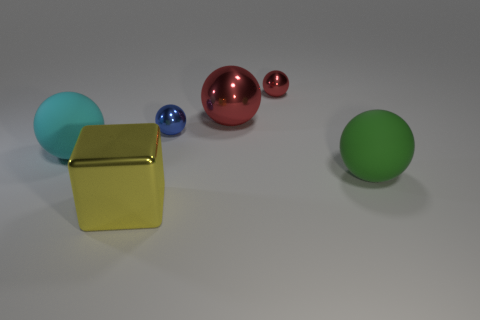Subtract all gray blocks. How many red balls are left? 2 Subtract all small blue metallic balls. How many balls are left? 4 Subtract 3 balls. How many balls are left? 2 Add 3 yellow metal things. How many objects exist? 9 Subtract all red balls. How many balls are left? 3 Subtract all purple spheres. Subtract all cyan cubes. How many spheres are left? 5 Subtract all spheres. How many objects are left? 1 Subtract 1 yellow blocks. How many objects are left? 5 Subtract all big rubber objects. Subtract all big cyan balls. How many objects are left? 3 Add 4 tiny red spheres. How many tiny red spheres are left? 5 